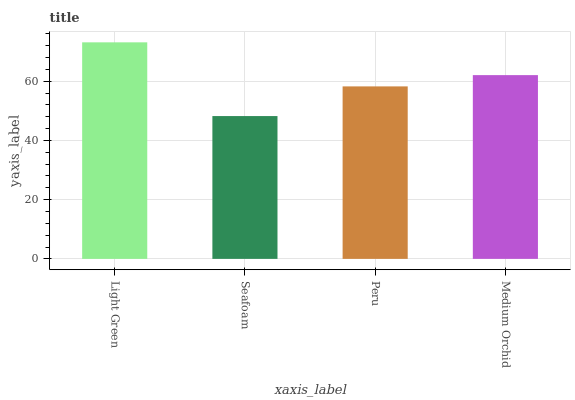Is Seafoam the minimum?
Answer yes or no. Yes. Is Light Green the maximum?
Answer yes or no. Yes. Is Peru the minimum?
Answer yes or no. No. Is Peru the maximum?
Answer yes or no. No. Is Peru greater than Seafoam?
Answer yes or no. Yes. Is Seafoam less than Peru?
Answer yes or no. Yes. Is Seafoam greater than Peru?
Answer yes or no. No. Is Peru less than Seafoam?
Answer yes or no. No. Is Medium Orchid the high median?
Answer yes or no. Yes. Is Peru the low median?
Answer yes or no. Yes. Is Seafoam the high median?
Answer yes or no. No. Is Seafoam the low median?
Answer yes or no. No. 